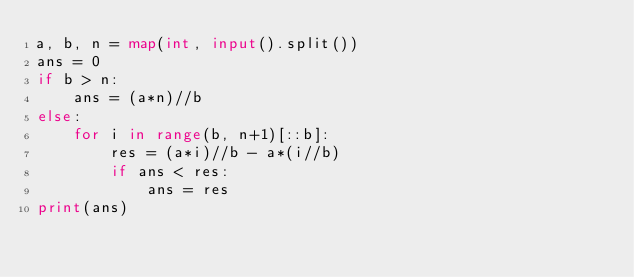Convert code to text. <code><loc_0><loc_0><loc_500><loc_500><_Python_>a, b, n = map(int, input().split())
ans = 0
if b > n:
    ans = (a*n)//b
else:
    for i in range(b, n+1)[::b]:
        res = (a*i)//b - a*(i//b)
        if ans < res:
            ans = res
print(ans)</code> 